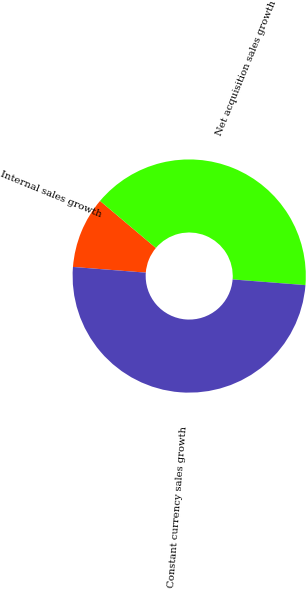<chart> <loc_0><loc_0><loc_500><loc_500><pie_chart><fcel>Internal sales growth<fcel>Net acquisition sales growth<fcel>Constant currency sales growth<nl><fcel>9.9%<fcel>40.1%<fcel>50.0%<nl></chart> 